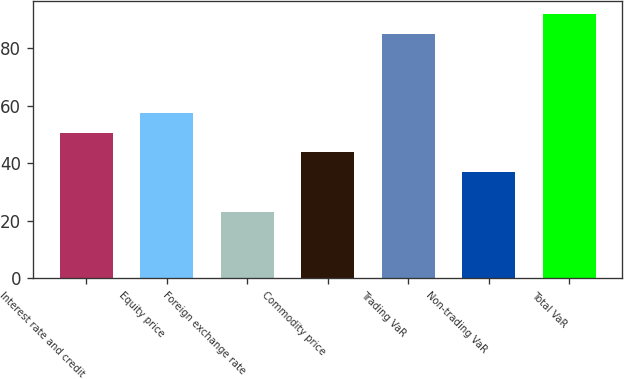Convert chart. <chart><loc_0><loc_0><loc_500><loc_500><bar_chart><fcel>Interest rate and credit<fcel>Equity price<fcel>Foreign exchange rate<fcel>Commodity price<fcel>Trading VaR<fcel>Non-trading VaR<fcel>Total VaR<nl><fcel>50.6<fcel>57.4<fcel>23<fcel>43.8<fcel>85<fcel>37<fcel>91.8<nl></chart> 